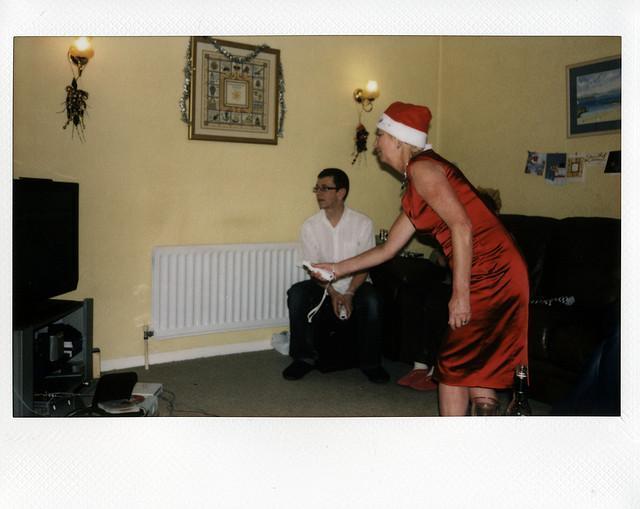How many people can you see?
Give a very brief answer. 2. 